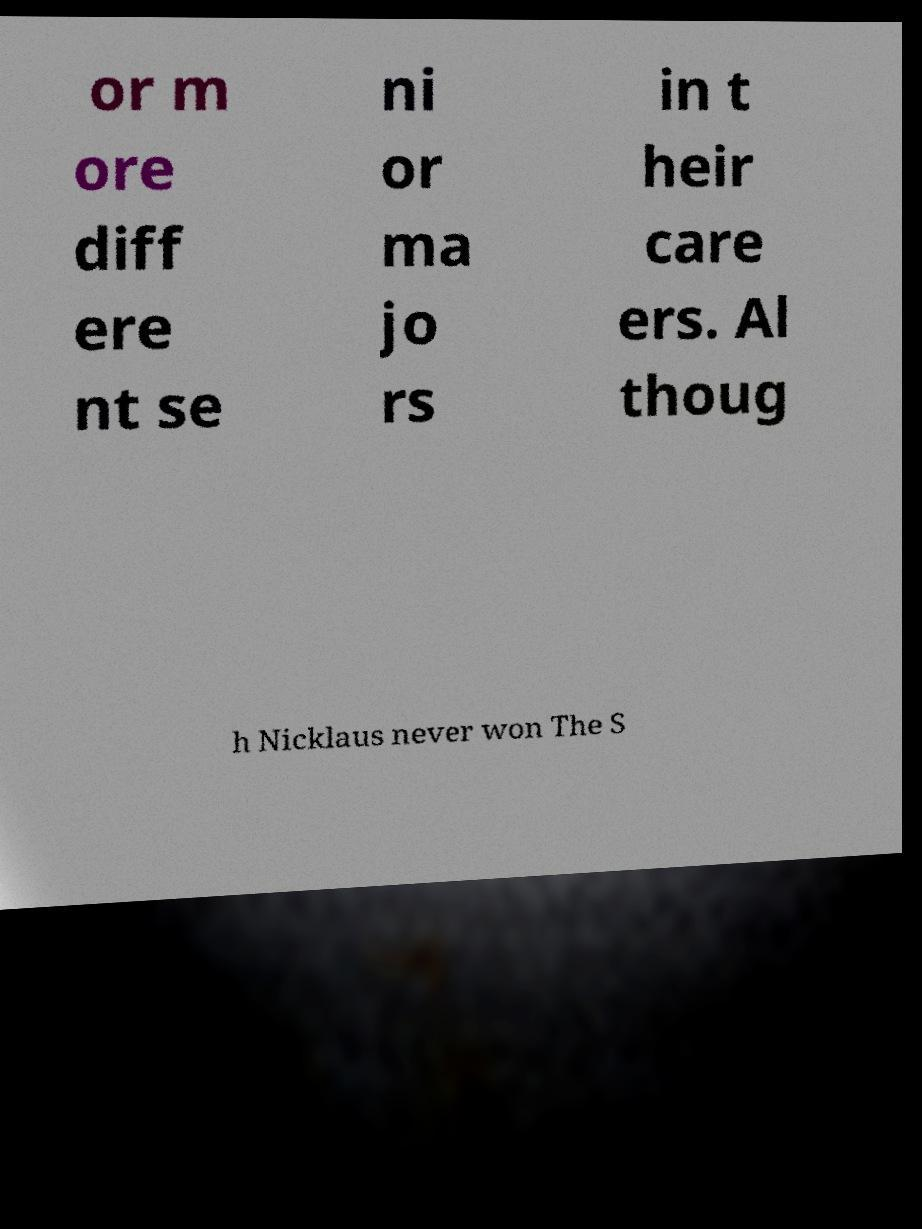What messages or text are displayed in this image? I need them in a readable, typed format. or m ore diff ere nt se ni or ma jo rs in t heir care ers. Al thoug h Nicklaus never won The S 